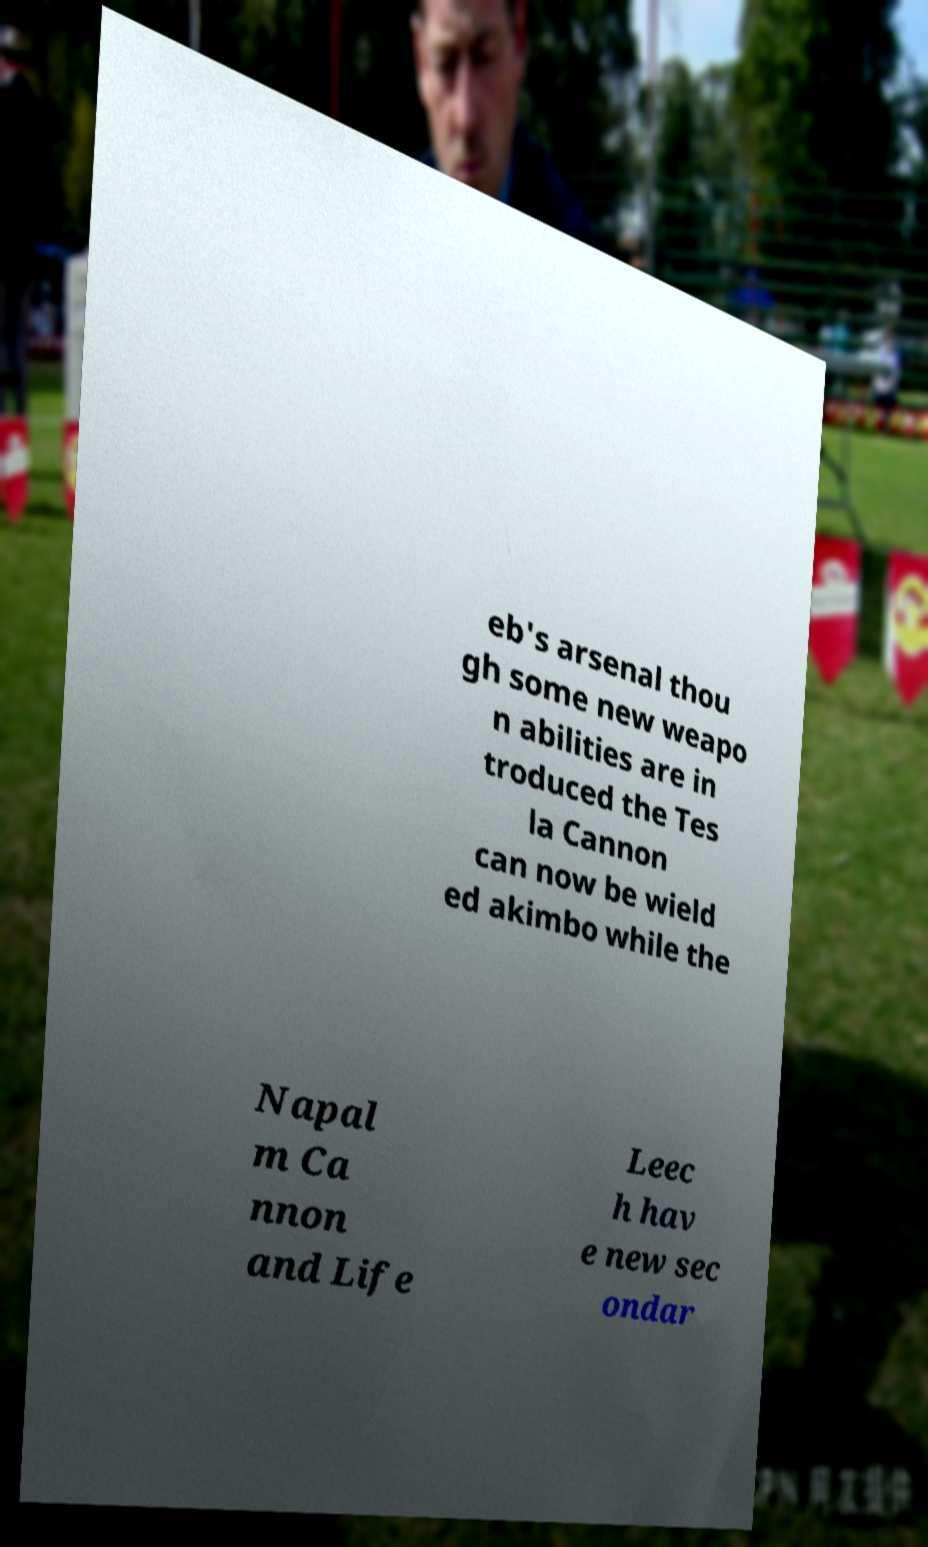I need the written content from this picture converted into text. Can you do that? eb's arsenal thou gh some new weapo n abilities are in troduced the Tes la Cannon can now be wield ed akimbo while the Napal m Ca nnon and Life Leec h hav e new sec ondar 